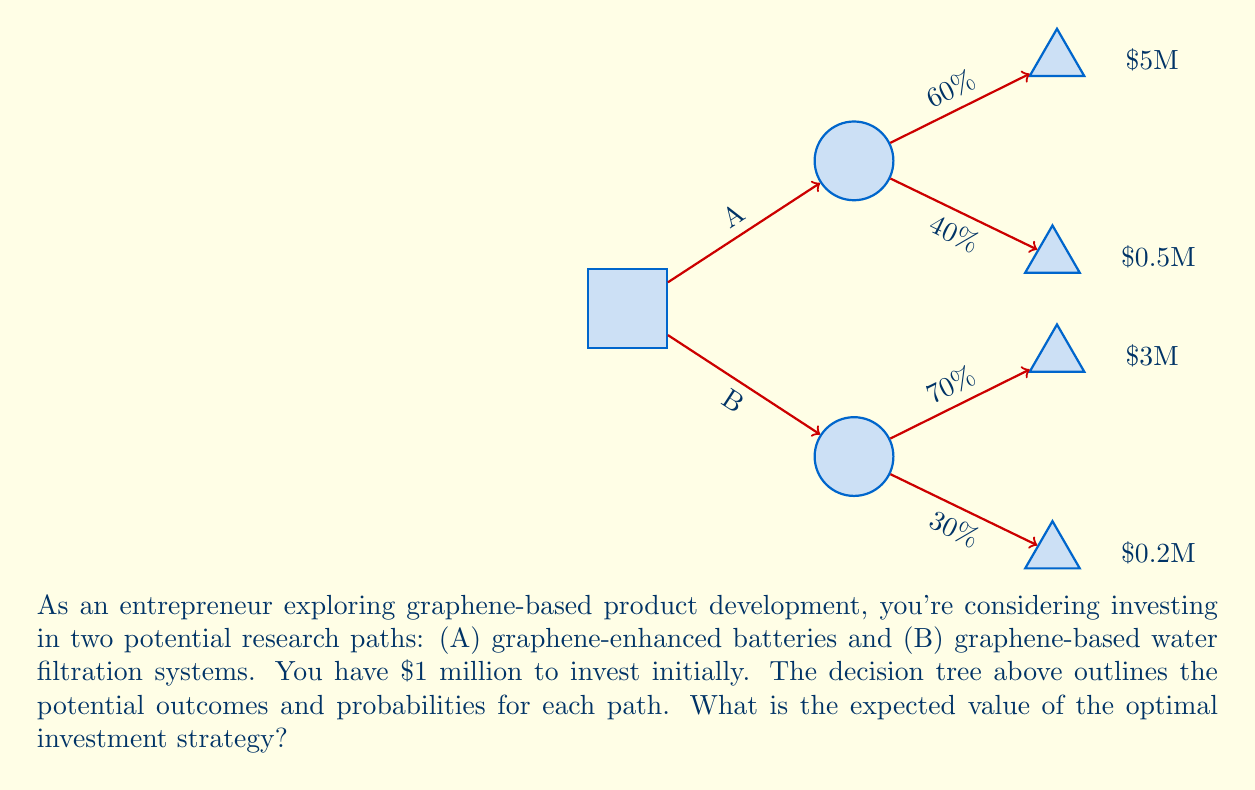Teach me how to tackle this problem. Let's solve this problem step by step using decision tree analysis:

1) First, calculate the expected value (EV) for path A:
   $$EV(A) = 0.60 \times \$5M + 0.40 \times \$0.5M$$
   $$EV(A) = \$3M + \$0.2M = \$3.2M$$

2) Now, calculate the expected value for path B:
   $$EV(B) = 0.70 \times \$3M + 0.30 \times \$0.2M$$
   $$EV(B) = \$2.1M + \$0.06M = \$2.16M$$

3) Compare the expected values:
   Path A: $3.2M
   Path B: $2.16M

4) The optimal strategy is to choose the path with the higher expected value, which is Path A (graphene-enhanced batteries).

5) To calculate the final expected value, we need to subtract the initial investment:
   $$EV(\text{optimal}) = EV(A) - \text{Initial Investment}$$
   $$EV(\text{optimal}) = \$3.2M - \$1M = \$2.2M$$

Therefore, the expected value of the optimal investment strategy is $2.2 million.
Answer: $2.2 million 